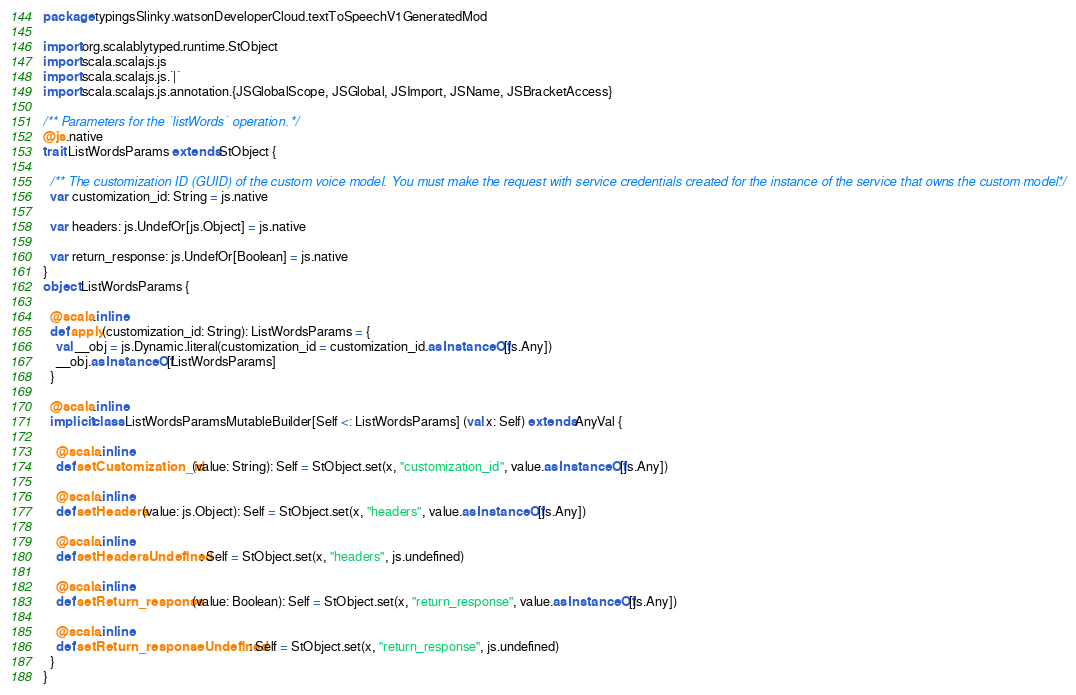<code> <loc_0><loc_0><loc_500><loc_500><_Scala_>package typingsSlinky.watsonDeveloperCloud.textToSpeechV1GeneratedMod

import org.scalablytyped.runtime.StObject
import scala.scalajs.js
import scala.scalajs.js.`|`
import scala.scalajs.js.annotation.{JSGlobalScope, JSGlobal, JSImport, JSName, JSBracketAccess}

/** Parameters for the `listWords` operation. */
@js.native
trait ListWordsParams extends StObject {
  
  /** The customization ID (GUID) of the custom voice model. You must make the request with service credentials created for the instance of the service that owns the custom model. */
  var customization_id: String = js.native
  
  var headers: js.UndefOr[js.Object] = js.native
  
  var return_response: js.UndefOr[Boolean] = js.native
}
object ListWordsParams {
  
  @scala.inline
  def apply(customization_id: String): ListWordsParams = {
    val __obj = js.Dynamic.literal(customization_id = customization_id.asInstanceOf[js.Any])
    __obj.asInstanceOf[ListWordsParams]
  }
  
  @scala.inline
  implicit class ListWordsParamsMutableBuilder[Self <: ListWordsParams] (val x: Self) extends AnyVal {
    
    @scala.inline
    def setCustomization_id(value: String): Self = StObject.set(x, "customization_id", value.asInstanceOf[js.Any])
    
    @scala.inline
    def setHeaders(value: js.Object): Self = StObject.set(x, "headers", value.asInstanceOf[js.Any])
    
    @scala.inline
    def setHeadersUndefined: Self = StObject.set(x, "headers", js.undefined)
    
    @scala.inline
    def setReturn_response(value: Boolean): Self = StObject.set(x, "return_response", value.asInstanceOf[js.Any])
    
    @scala.inline
    def setReturn_responseUndefined: Self = StObject.set(x, "return_response", js.undefined)
  }
}
</code> 